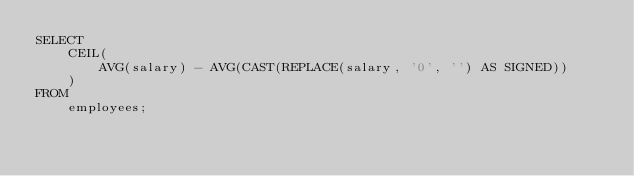<code> <loc_0><loc_0><loc_500><loc_500><_SQL_>SELECT
    CEIL(
        AVG(salary) - AVG(CAST(REPLACE(salary, '0', '') AS SIGNED))
    )
FROM
    employees;</code> 